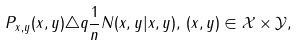Convert formula to latex. <formula><loc_0><loc_0><loc_500><loc_500>P _ { x , y } ( x , y ) \triangle q \frac { 1 } { n } N ( x , y | x , y ) , \, ( x , y ) \in \mathcal { X } \times \mathcal { Y } ,</formula> 